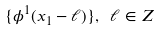<formula> <loc_0><loc_0><loc_500><loc_500>\{ \phi ^ { 1 } ( x _ { 1 } - \ell ) \} , \ \ell \in Z</formula> 